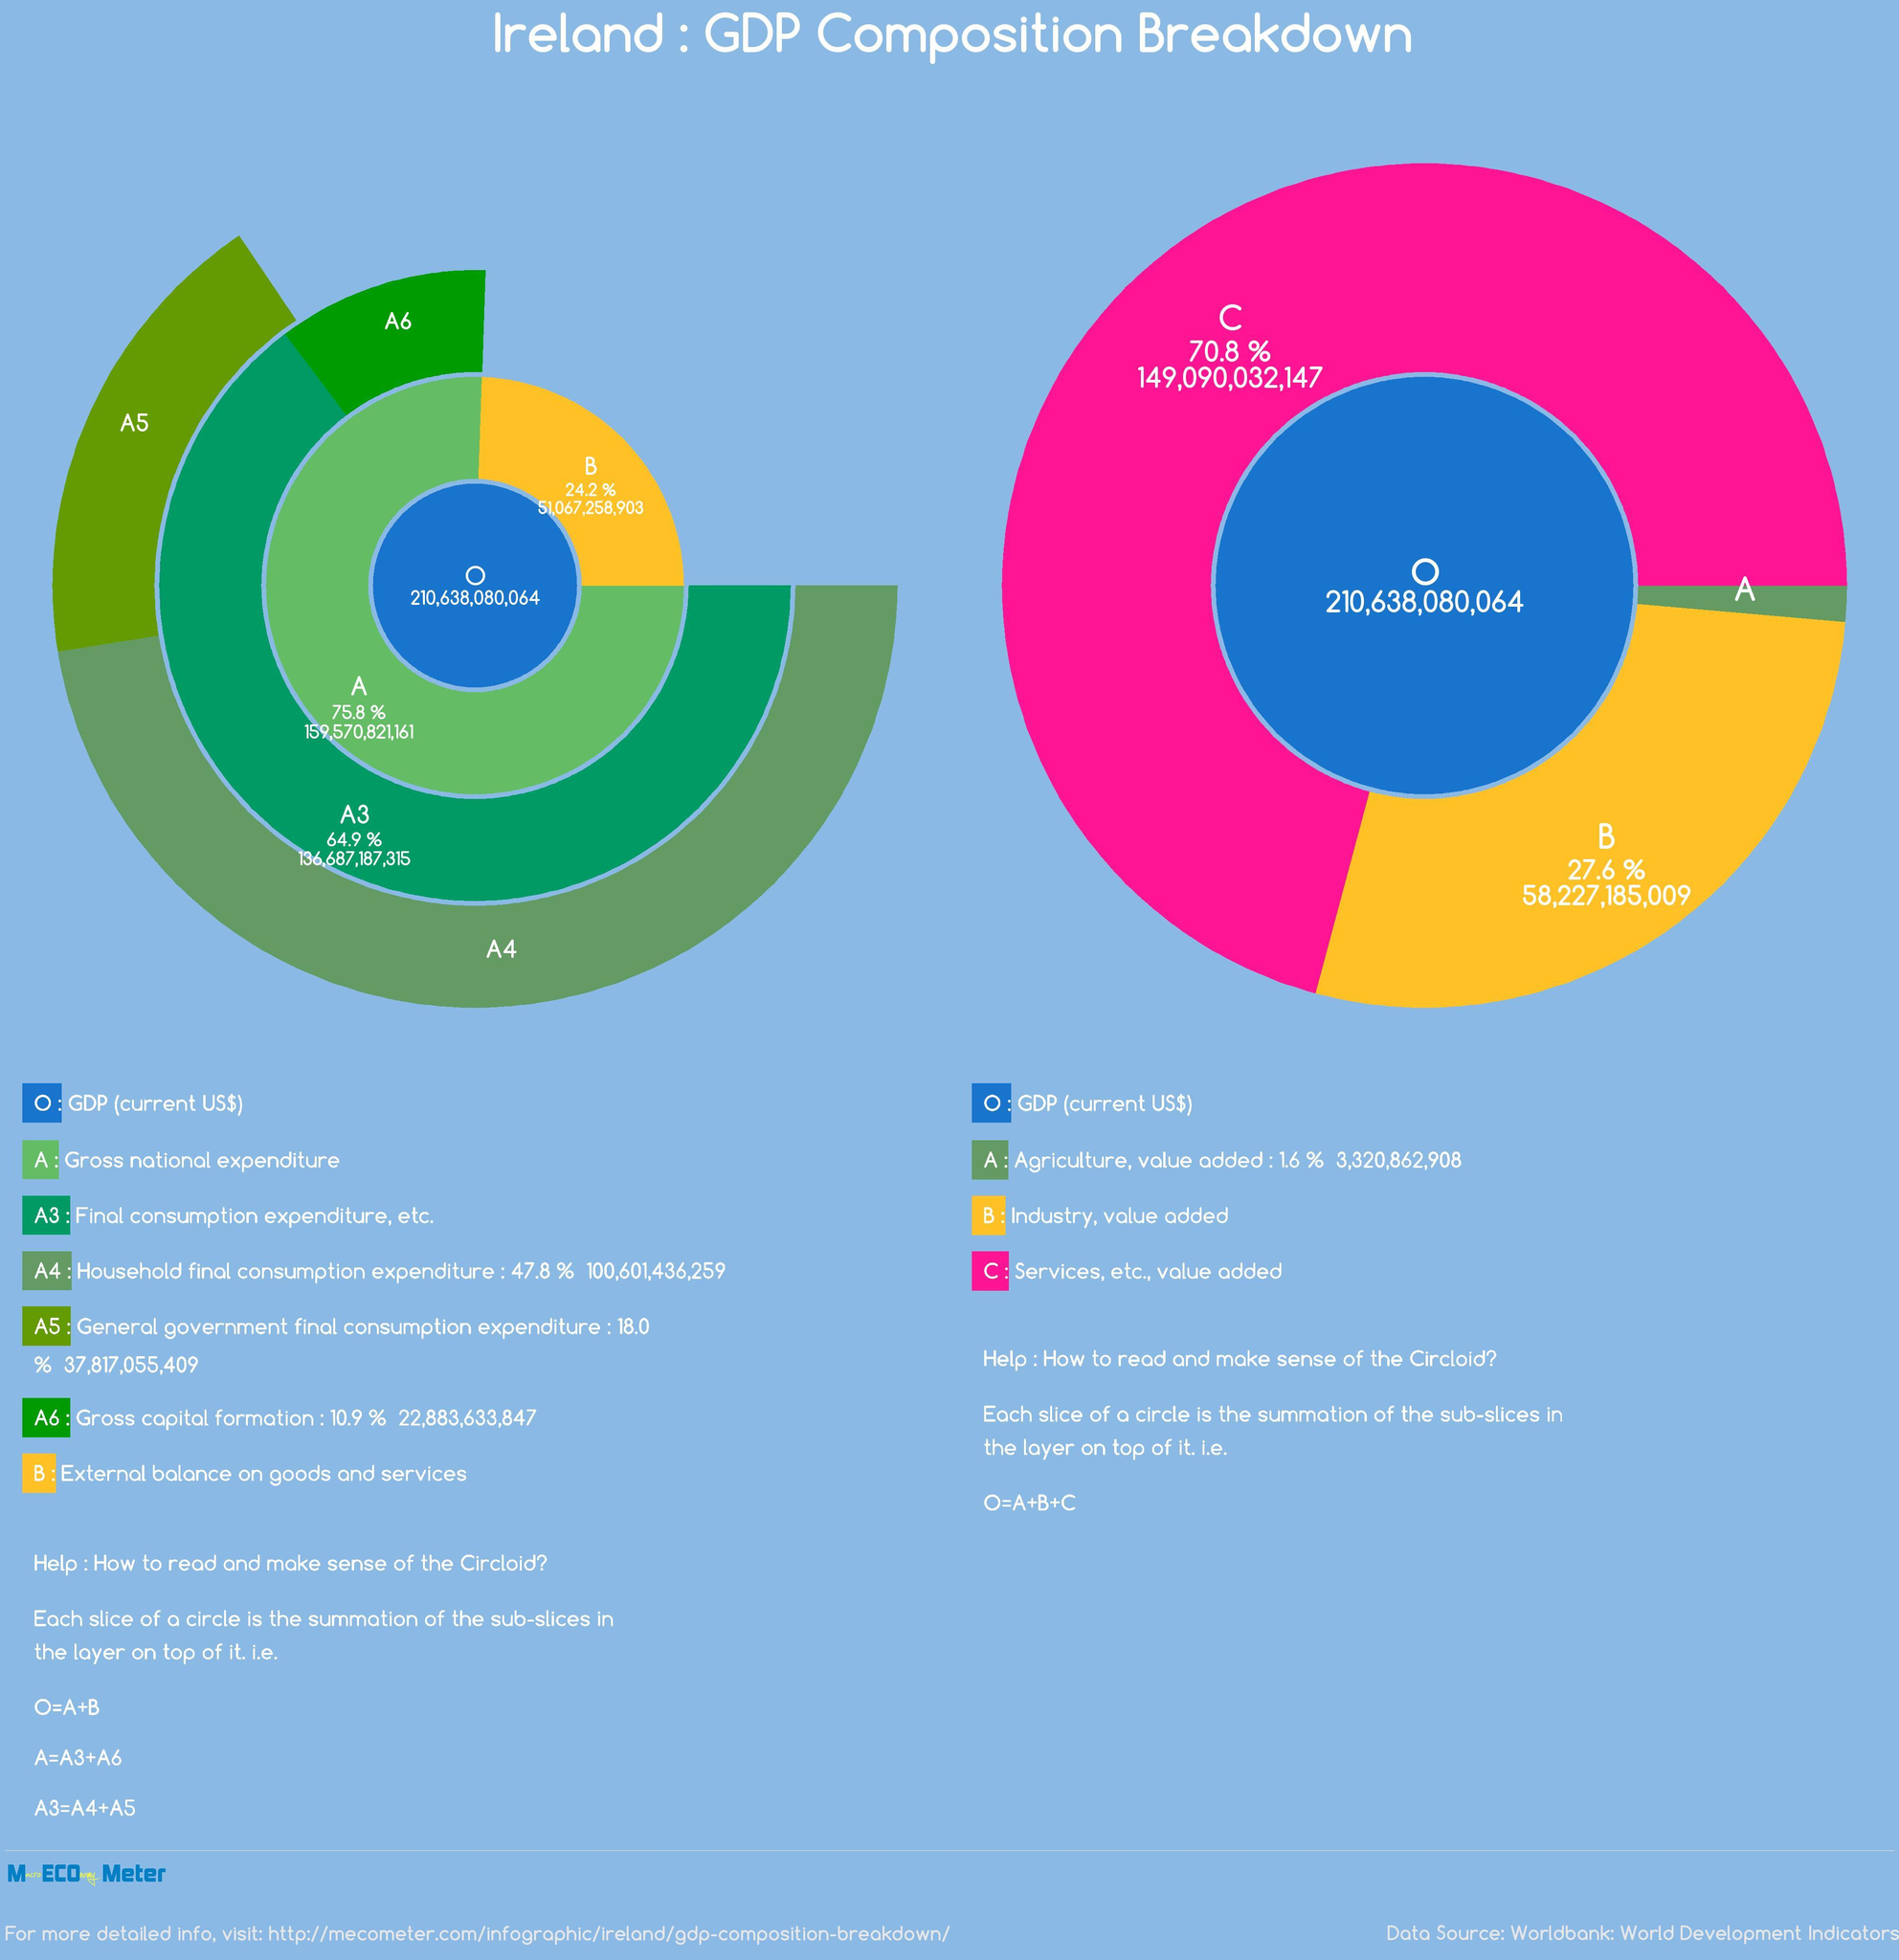The industry is represented by which color-pink, orange, or green?
Answer the question with a short phrase. orange Which has the highest share-B, C? C Which has the highest share-A3, A? A The service is represented by which color-orange, pink, green? pink 